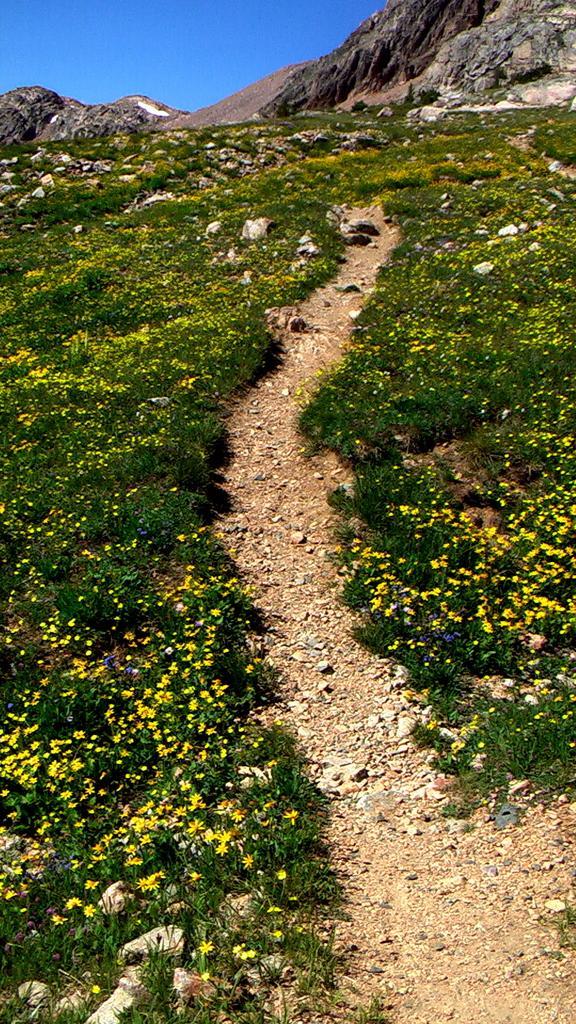In one or two sentences, can you explain what this image depicts? In the foreground of this picture, there is a path on a mountain to which plants with flowers on the either side to the path. In the background, there are cliffs and the sky. 